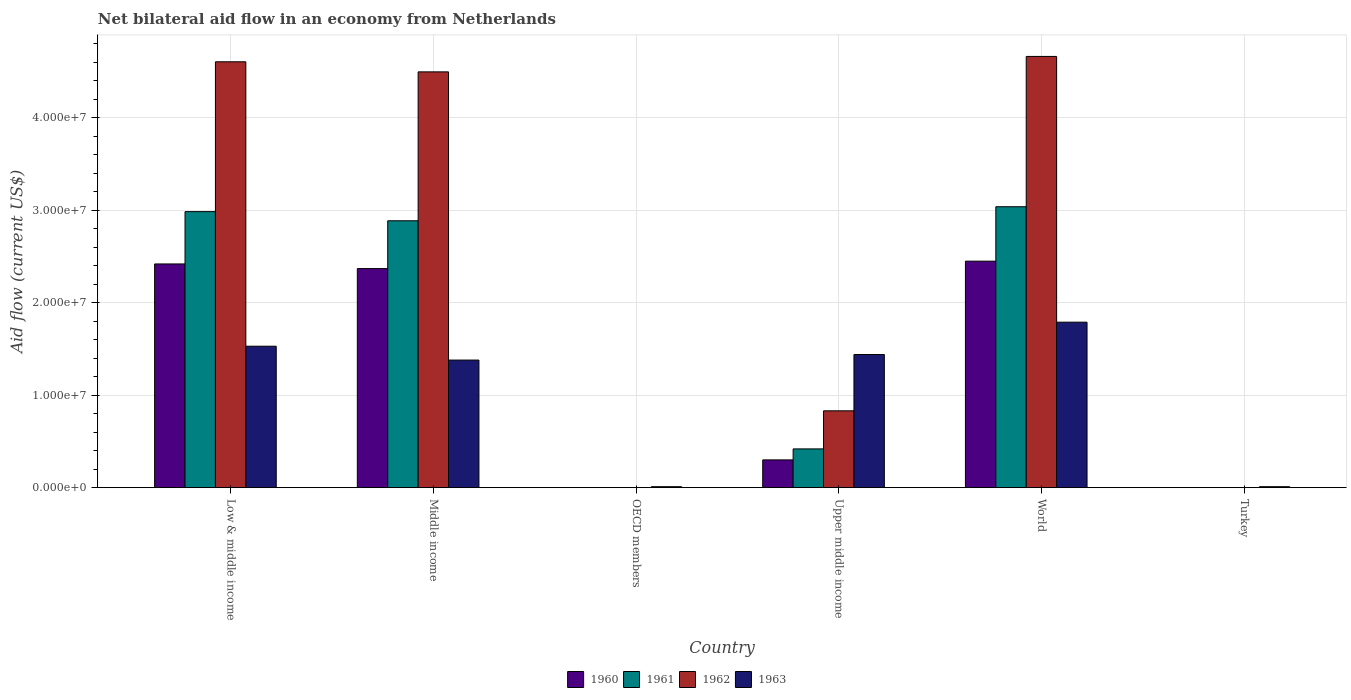How many different coloured bars are there?
Keep it short and to the point. 4. How many bars are there on the 5th tick from the right?
Your response must be concise. 4. What is the label of the 5th group of bars from the left?
Offer a terse response. World. What is the net bilateral aid flow in 1960 in Turkey?
Provide a short and direct response. 0. Across all countries, what is the maximum net bilateral aid flow in 1963?
Offer a terse response. 1.79e+07. Across all countries, what is the minimum net bilateral aid flow in 1962?
Offer a very short reply. 0. What is the total net bilateral aid flow in 1960 in the graph?
Keep it short and to the point. 7.54e+07. What is the difference between the net bilateral aid flow in 1963 in Upper middle income and the net bilateral aid flow in 1960 in Turkey?
Give a very brief answer. 1.44e+07. What is the average net bilateral aid flow in 1960 per country?
Offer a very short reply. 1.26e+07. What is the difference between the net bilateral aid flow of/in 1961 and net bilateral aid flow of/in 1963 in Upper middle income?
Give a very brief answer. -1.02e+07. What is the ratio of the net bilateral aid flow in 1963 in OECD members to that in Turkey?
Give a very brief answer. 1. Is the net bilateral aid flow in 1962 in Low & middle income less than that in Middle income?
Offer a terse response. No. What is the difference between the highest and the second highest net bilateral aid flow in 1963?
Give a very brief answer. 3.50e+06. What is the difference between the highest and the lowest net bilateral aid flow in 1961?
Provide a succinct answer. 3.04e+07. In how many countries, is the net bilateral aid flow in 1963 greater than the average net bilateral aid flow in 1963 taken over all countries?
Keep it short and to the point. 4. Is the sum of the net bilateral aid flow in 1963 in OECD members and World greater than the maximum net bilateral aid flow in 1961 across all countries?
Provide a short and direct response. No. Is it the case that in every country, the sum of the net bilateral aid flow in 1963 and net bilateral aid flow in 1961 is greater than the sum of net bilateral aid flow in 1960 and net bilateral aid flow in 1962?
Keep it short and to the point. No. How many bars are there?
Make the answer very short. 18. Are all the bars in the graph horizontal?
Your answer should be very brief. No. What is the difference between two consecutive major ticks on the Y-axis?
Make the answer very short. 1.00e+07. Where does the legend appear in the graph?
Keep it short and to the point. Bottom center. What is the title of the graph?
Give a very brief answer. Net bilateral aid flow in an economy from Netherlands. Does "2002" appear as one of the legend labels in the graph?
Provide a succinct answer. No. What is the Aid flow (current US$) in 1960 in Low & middle income?
Make the answer very short. 2.42e+07. What is the Aid flow (current US$) of 1961 in Low & middle income?
Make the answer very short. 2.99e+07. What is the Aid flow (current US$) in 1962 in Low & middle income?
Make the answer very short. 4.61e+07. What is the Aid flow (current US$) of 1963 in Low & middle income?
Your answer should be very brief. 1.53e+07. What is the Aid flow (current US$) of 1960 in Middle income?
Your response must be concise. 2.37e+07. What is the Aid flow (current US$) of 1961 in Middle income?
Give a very brief answer. 2.89e+07. What is the Aid flow (current US$) of 1962 in Middle income?
Offer a very short reply. 4.50e+07. What is the Aid flow (current US$) in 1963 in Middle income?
Offer a terse response. 1.38e+07. What is the Aid flow (current US$) in 1960 in OECD members?
Offer a very short reply. 0. What is the Aid flow (current US$) of 1962 in OECD members?
Provide a succinct answer. 0. What is the Aid flow (current US$) of 1961 in Upper middle income?
Offer a very short reply. 4.19e+06. What is the Aid flow (current US$) of 1962 in Upper middle income?
Provide a succinct answer. 8.31e+06. What is the Aid flow (current US$) of 1963 in Upper middle income?
Your response must be concise. 1.44e+07. What is the Aid flow (current US$) in 1960 in World?
Provide a short and direct response. 2.45e+07. What is the Aid flow (current US$) in 1961 in World?
Your response must be concise. 3.04e+07. What is the Aid flow (current US$) in 1962 in World?
Provide a short and direct response. 4.66e+07. What is the Aid flow (current US$) in 1963 in World?
Make the answer very short. 1.79e+07. What is the Aid flow (current US$) in 1960 in Turkey?
Ensure brevity in your answer.  0. What is the Aid flow (current US$) of 1961 in Turkey?
Provide a succinct answer. 0. What is the Aid flow (current US$) in 1962 in Turkey?
Offer a very short reply. 0. What is the Aid flow (current US$) of 1963 in Turkey?
Offer a terse response. 1.00e+05. Across all countries, what is the maximum Aid flow (current US$) in 1960?
Your answer should be compact. 2.45e+07. Across all countries, what is the maximum Aid flow (current US$) of 1961?
Your answer should be compact. 3.04e+07. Across all countries, what is the maximum Aid flow (current US$) of 1962?
Offer a very short reply. 4.66e+07. Across all countries, what is the maximum Aid flow (current US$) in 1963?
Your answer should be compact. 1.79e+07. Across all countries, what is the minimum Aid flow (current US$) in 1961?
Ensure brevity in your answer.  0. Across all countries, what is the minimum Aid flow (current US$) of 1962?
Give a very brief answer. 0. What is the total Aid flow (current US$) of 1960 in the graph?
Provide a short and direct response. 7.54e+07. What is the total Aid flow (current US$) of 1961 in the graph?
Ensure brevity in your answer.  9.33e+07. What is the total Aid flow (current US$) of 1962 in the graph?
Keep it short and to the point. 1.46e+08. What is the total Aid flow (current US$) in 1963 in the graph?
Your answer should be very brief. 6.16e+07. What is the difference between the Aid flow (current US$) in 1961 in Low & middle income and that in Middle income?
Offer a very short reply. 9.90e+05. What is the difference between the Aid flow (current US$) of 1962 in Low & middle income and that in Middle income?
Offer a very short reply. 1.09e+06. What is the difference between the Aid flow (current US$) of 1963 in Low & middle income and that in Middle income?
Your answer should be compact. 1.50e+06. What is the difference between the Aid flow (current US$) of 1963 in Low & middle income and that in OECD members?
Offer a terse response. 1.52e+07. What is the difference between the Aid flow (current US$) in 1960 in Low & middle income and that in Upper middle income?
Your answer should be very brief. 2.12e+07. What is the difference between the Aid flow (current US$) of 1961 in Low & middle income and that in Upper middle income?
Keep it short and to the point. 2.57e+07. What is the difference between the Aid flow (current US$) in 1962 in Low & middle income and that in Upper middle income?
Your answer should be compact. 3.78e+07. What is the difference between the Aid flow (current US$) of 1963 in Low & middle income and that in Upper middle income?
Offer a very short reply. 9.00e+05. What is the difference between the Aid flow (current US$) of 1960 in Low & middle income and that in World?
Provide a short and direct response. -3.00e+05. What is the difference between the Aid flow (current US$) of 1961 in Low & middle income and that in World?
Ensure brevity in your answer.  -5.30e+05. What is the difference between the Aid flow (current US$) in 1962 in Low & middle income and that in World?
Keep it short and to the point. -5.80e+05. What is the difference between the Aid flow (current US$) in 1963 in Low & middle income and that in World?
Give a very brief answer. -2.60e+06. What is the difference between the Aid flow (current US$) of 1963 in Low & middle income and that in Turkey?
Provide a short and direct response. 1.52e+07. What is the difference between the Aid flow (current US$) in 1963 in Middle income and that in OECD members?
Keep it short and to the point. 1.37e+07. What is the difference between the Aid flow (current US$) in 1960 in Middle income and that in Upper middle income?
Provide a short and direct response. 2.07e+07. What is the difference between the Aid flow (current US$) of 1961 in Middle income and that in Upper middle income?
Your response must be concise. 2.47e+07. What is the difference between the Aid flow (current US$) of 1962 in Middle income and that in Upper middle income?
Keep it short and to the point. 3.67e+07. What is the difference between the Aid flow (current US$) in 1963 in Middle income and that in Upper middle income?
Your answer should be very brief. -6.00e+05. What is the difference between the Aid flow (current US$) in 1960 in Middle income and that in World?
Your answer should be very brief. -8.00e+05. What is the difference between the Aid flow (current US$) of 1961 in Middle income and that in World?
Ensure brevity in your answer.  -1.52e+06. What is the difference between the Aid flow (current US$) in 1962 in Middle income and that in World?
Give a very brief answer. -1.67e+06. What is the difference between the Aid flow (current US$) of 1963 in Middle income and that in World?
Offer a terse response. -4.10e+06. What is the difference between the Aid flow (current US$) in 1963 in Middle income and that in Turkey?
Your answer should be compact. 1.37e+07. What is the difference between the Aid flow (current US$) in 1963 in OECD members and that in Upper middle income?
Your answer should be compact. -1.43e+07. What is the difference between the Aid flow (current US$) of 1963 in OECD members and that in World?
Keep it short and to the point. -1.78e+07. What is the difference between the Aid flow (current US$) of 1963 in OECD members and that in Turkey?
Ensure brevity in your answer.  0. What is the difference between the Aid flow (current US$) of 1960 in Upper middle income and that in World?
Ensure brevity in your answer.  -2.15e+07. What is the difference between the Aid flow (current US$) in 1961 in Upper middle income and that in World?
Keep it short and to the point. -2.62e+07. What is the difference between the Aid flow (current US$) in 1962 in Upper middle income and that in World?
Provide a short and direct response. -3.83e+07. What is the difference between the Aid flow (current US$) in 1963 in Upper middle income and that in World?
Make the answer very short. -3.50e+06. What is the difference between the Aid flow (current US$) in 1963 in Upper middle income and that in Turkey?
Make the answer very short. 1.43e+07. What is the difference between the Aid flow (current US$) of 1963 in World and that in Turkey?
Provide a short and direct response. 1.78e+07. What is the difference between the Aid flow (current US$) of 1960 in Low & middle income and the Aid flow (current US$) of 1961 in Middle income?
Provide a succinct answer. -4.67e+06. What is the difference between the Aid flow (current US$) in 1960 in Low & middle income and the Aid flow (current US$) in 1962 in Middle income?
Provide a short and direct response. -2.08e+07. What is the difference between the Aid flow (current US$) in 1960 in Low & middle income and the Aid flow (current US$) in 1963 in Middle income?
Your answer should be compact. 1.04e+07. What is the difference between the Aid flow (current US$) of 1961 in Low & middle income and the Aid flow (current US$) of 1962 in Middle income?
Keep it short and to the point. -1.51e+07. What is the difference between the Aid flow (current US$) in 1961 in Low & middle income and the Aid flow (current US$) in 1963 in Middle income?
Your answer should be compact. 1.61e+07. What is the difference between the Aid flow (current US$) of 1962 in Low & middle income and the Aid flow (current US$) of 1963 in Middle income?
Make the answer very short. 3.23e+07. What is the difference between the Aid flow (current US$) in 1960 in Low & middle income and the Aid flow (current US$) in 1963 in OECD members?
Your answer should be compact. 2.41e+07. What is the difference between the Aid flow (current US$) in 1961 in Low & middle income and the Aid flow (current US$) in 1963 in OECD members?
Ensure brevity in your answer.  2.98e+07. What is the difference between the Aid flow (current US$) of 1962 in Low & middle income and the Aid flow (current US$) of 1963 in OECD members?
Your answer should be compact. 4.60e+07. What is the difference between the Aid flow (current US$) in 1960 in Low & middle income and the Aid flow (current US$) in 1961 in Upper middle income?
Make the answer very short. 2.00e+07. What is the difference between the Aid flow (current US$) in 1960 in Low & middle income and the Aid flow (current US$) in 1962 in Upper middle income?
Give a very brief answer. 1.59e+07. What is the difference between the Aid flow (current US$) in 1960 in Low & middle income and the Aid flow (current US$) in 1963 in Upper middle income?
Make the answer very short. 9.80e+06. What is the difference between the Aid flow (current US$) of 1961 in Low & middle income and the Aid flow (current US$) of 1962 in Upper middle income?
Give a very brief answer. 2.16e+07. What is the difference between the Aid flow (current US$) of 1961 in Low & middle income and the Aid flow (current US$) of 1963 in Upper middle income?
Offer a terse response. 1.55e+07. What is the difference between the Aid flow (current US$) of 1962 in Low & middle income and the Aid flow (current US$) of 1963 in Upper middle income?
Your answer should be very brief. 3.17e+07. What is the difference between the Aid flow (current US$) in 1960 in Low & middle income and the Aid flow (current US$) in 1961 in World?
Your response must be concise. -6.19e+06. What is the difference between the Aid flow (current US$) in 1960 in Low & middle income and the Aid flow (current US$) in 1962 in World?
Offer a terse response. -2.24e+07. What is the difference between the Aid flow (current US$) in 1960 in Low & middle income and the Aid flow (current US$) in 1963 in World?
Your response must be concise. 6.30e+06. What is the difference between the Aid flow (current US$) of 1961 in Low & middle income and the Aid flow (current US$) of 1962 in World?
Your answer should be very brief. -1.68e+07. What is the difference between the Aid flow (current US$) in 1961 in Low & middle income and the Aid flow (current US$) in 1963 in World?
Provide a short and direct response. 1.20e+07. What is the difference between the Aid flow (current US$) of 1962 in Low & middle income and the Aid flow (current US$) of 1963 in World?
Make the answer very short. 2.82e+07. What is the difference between the Aid flow (current US$) in 1960 in Low & middle income and the Aid flow (current US$) in 1963 in Turkey?
Keep it short and to the point. 2.41e+07. What is the difference between the Aid flow (current US$) of 1961 in Low & middle income and the Aid flow (current US$) of 1963 in Turkey?
Offer a terse response. 2.98e+07. What is the difference between the Aid flow (current US$) in 1962 in Low & middle income and the Aid flow (current US$) in 1963 in Turkey?
Ensure brevity in your answer.  4.60e+07. What is the difference between the Aid flow (current US$) in 1960 in Middle income and the Aid flow (current US$) in 1963 in OECD members?
Offer a very short reply. 2.36e+07. What is the difference between the Aid flow (current US$) of 1961 in Middle income and the Aid flow (current US$) of 1963 in OECD members?
Give a very brief answer. 2.88e+07. What is the difference between the Aid flow (current US$) in 1962 in Middle income and the Aid flow (current US$) in 1963 in OECD members?
Make the answer very short. 4.49e+07. What is the difference between the Aid flow (current US$) in 1960 in Middle income and the Aid flow (current US$) in 1961 in Upper middle income?
Your response must be concise. 1.95e+07. What is the difference between the Aid flow (current US$) of 1960 in Middle income and the Aid flow (current US$) of 1962 in Upper middle income?
Your answer should be compact. 1.54e+07. What is the difference between the Aid flow (current US$) in 1960 in Middle income and the Aid flow (current US$) in 1963 in Upper middle income?
Ensure brevity in your answer.  9.30e+06. What is the difference between the Aid flow (current US$) in 1961 in Middle income and the Aid flow (current US$) in 1962 in Upper middle income?
Provide a short and direct response. 2.06e+07. What is the difference between the Aid flow (current US$) of 1961 in Middle income and the Aid flow (current US$) of 1963 in Upper middle income?
Offer a terse response. 1.45e+07. What is the difference between the Aid flow (current US$) in 1962 in Middle income and the Aid flow (current US$) in 1963 in Upper middle income?
Ensure brevity in your answer.  3.06e+07. What is the difference between the Aid flow (current US$) of 1960 in Middle income and the Aid flow (current US$) of 1961 in World?
Provide a succinct answer. -6.69e+06. What is the difference between the Aid flow (current US$) in 1960 in Middle income and the Aid flow (current US$) in 1962 in World?
Offer a terse response. -2.30e+07. What is the difference between the Aid flow (current US$) in 1960 in Middle income and the Aid flow (current US$) in 1963 in World?
Keep it short and to the point. 5.80e+06. What is the difference between the Aid flow (current US$) in 1961 in Middle income and the Aid flow (current US$) in 1962 in World?
Offer a very short reply. -1.78e+07. What is the difference between the Aid flow (current US$) in 1961 in Middle income and the Aid flow (current US$) in 1963 in World?
Ensure brevity in your answer.  1.10e+07. What is the difference between the Aid flow (current US$) in 1962 in Middle income and the Aid flow (current US$) in 1963 in World?
Give a very brief answer. 2.71e+07. What is the difference between the Aid flow (current US$) of 1960 in Middle income and the Aid flow (current US$) of 1963 in Turkey?
Give a very brief answer. 2.36e+07. What is the difference between the Aid flow (current US$) in 1961 in Middle income and the Aid flow (current US$) in 1963 in Turkey?
Provide a succinct answer. 2.88e+07. What is the difference between the Aid flow (current US$) in 1962 in Middle income and the Aid flow (current US$) in 1963 in Turkey?
Your answer should be very brief. 4.49e+07. What is the difference between the Aid flow (current US$) in 1960 in Upper middle income and the Aid flow (current US$) in 1961 in World?
Offer a very short reply. -2.74e+07. What is the difference between the Aid flow (current US$) in 1960 in Upper middle income and the Aid flow (current US$) in 1962 in World?
Provide a short and direct response. -4.36e+07. What is the difference between the Aid flow (current US$) in 1960 in Upper middle income and the Aid flow (current US$) in 1963 in World?
Your answer should be very brief. -1.49e+07. What is the difference between the Aid flow (current US$) of 1961 in Upper middle income and the Aid flow (current US$) of 1962 in World?
Keep it short and to the point. -4.25e+07. What is the difference between the Aid flow (current US$) in 1961 in Upper middle income and the Aid flow (current US$) in 1963 in World?
Give a very brief answer. -1.37e+07. What is the difference between the Aid flow (current US$) of 1962 in Upper middle income and the Aid flow (current US$) of 1963 in World?
Your response must be concise. -9.59e+06. What is the difference between the Aid flow (current US$) of 1960 in Upper middle income and the Aid flow (current US$) of 1963 in Turkey?
Your answer should be very brief. 2.90e+06. What is the difference between the Aid flow (current US$) in 1961 in Upper middle income and the Aid flow (current US$) in 1963 in Turkey?
Offer a terse response. 4.09e+06. What is the difference between the Aid flow (current US$) in 1962 in Upper middle income and the Aid flow (current US$) in 1963 in Turkey?
Ensure brevity in your answer.  8.21e+06. What is the difference between the Aid flow (current US$) of 1960 in World and the Aid flow (current US$) of 1963 in Turkey?
Your answer should be compact. 2.44e+07. What is the difference between the Aid flow (current US$) in 1961 in World and the Aid flow (current US$) in 1963 in Turkey?
Make the answer very short. 3.03e+07. What is the difference between the Aid flow (current US$) in 1962 in World and the Aid flow (current US$) in 1963 in Turkey?
Make the answer very short. 4.66e+07. What is the average Aid flow (current US$) in 1960 per country?
Give a very brief answer. 1.26e+07. What is the average Aid flow (current US$) in 1961 per country?
Give a very brief answer. 1.56e+07. What is the average Aid flow (current US$) of 1962 per country?
Give a very brief answer. 2.43e+07. What is the average Aid flow (current US$) in 1963 per country?
Give a very brief answer. 1.03e+07. What is the difference between the Aid flow (current US$) of 1960 and Aid flow (current US$) of 1961 in Low & middle income?
Your answer should be compact. -5.66e+06. What is the difference between the Aid flow (current US$) in 1960 and Aid flow (current US$) in 1962 in Low & middle income?
Provide a short and direct response. -2.19e+07. What is the difference between the Aid flow (current US$) in 1960 and Aid flow (current US$) in 1963 in Low & middle income?
Give a very brief answer. 8.90e+06. What is the difference between the Aid flow (current US$) of 1961 and Aid flow (current US$) of 1962 in Low & middle income?
Provide a succinct answer. -1.62e+07. What is the difference between the Aid flow (current US$) in 1961 and Aid flow (current US$) in 1963 in Low & middle income?
Keep it short and to the point. 1.46e+07. What is the difference between the Aid flow (current US$) in 1962 and Aid flow (current US$) in 1963 in Low & middle income?
Ensure brevity in your answer.  3.08e+07. What is the difference between the Aid flow (current US$) of 1960 and Aid flow (current US$) of 1961 in Middle income?
Provide a succinct answer. -5.17e+06. What is the difference between the Aid flow (current US$) of 1960 and Aid flow (current US$) of 1962 in Middle income?
Offer a very short reply. -2.13e+07. What is the difference between the Aid flow (current US$) in 1960 and Aid flow (current US$) in 1963 in Middle income?
Make the answer very short. 9.90e+06. What is the difference between the Aid flow (current US$) in 1961 and Aid flow (current US$) in 1962 in Middle income?
Your answer should be compact. -1.61e+07. What is the difference between the Aid flow (current US$) of 1961 and Aid flow (current US$) of 1963 in Middle income?
Offer a very short reply. 1.51e+07. What is the difference between the Aid flow (current US$) of 1962 and Aid flow (current US$) of 1963 in Middle income?
Your answer should be very brief. 3.12e+07. What is the difference between the Aid flow (current US$) in 1960 and Aid flow (current US$) in 1961 in Upper middle income?
Your response must be concise. -1.19e+06. What is the difference between the Aid flow (current US$) of 1960 and Aid flow (current US$) of 1962 in Upper middle income?
Make the answer very short. -5.31e+06. What is the difference between the Aid flow (current US$) of 1960 and Aid flow (current US$) of 1963 in Upper middle income?
Ensure brevity in your answer.  -1.14e+07. What is the difference between the Aid flow (current US$) of 1961 and Aid flow (current US$) of 1962 in Upper middle income?
Make the answer very short. -4.12e+06. What is the difference between the Aid flow (current US$) of 1961 and Aid flow (current US$) of 1963 in Upper middle income?
Give a very brief answer. -1.02e+07. What is the difference between the Aid flow (current US$) of 1962 and Aid flow (current US$) of 1963 in Upper middle income?
Your response must be concise. -6.09e+06. What is the difference between the Aid flow (current US$) in 1960 and Aid flow (current US$) in 1961 in World?
Provide a short and direct response. -5.89e+06. What is the difference between the Aid flow (current US$) of 1960 and Aid flow (current US$) of 1962 in World?
Keep it short and to the point. -2.22e+07. What is the difference between the Aid flow (current US$) in 1960 and Aid flow (current US$) in 1963 in World?
Offer a terse response. 6.60e+06. What is the difference between the Aid flow (current US$) of 1961 and Aid flow (current US$) of 1962 in World?
Provide a short and direct response. -1.63e+07. What is the difference between the Aid flow (current US$) in 1961 and Aid flow (current US$) in 1963 in World?
Your answer should be very brief. 1.25e+07. What is the difference between the Aid flow (current US$) in 1962 and Aid flow (current US$) in 1963 in World?
Your answer should be very brief. 2.88e+07. What is the ratio of the Aid flow (current US$) of 1960 in Low & middle income to that in Middle income?
Your response must be concise. 1.02. What is the ratio of the Aid flow (current US$) in 1961 in Low & middle income to that in Middle income?
Provide a short and direct response. 1.03. What is the ratio of the Aid flow (current US$) in 1962 in Low & middle income to that in Middle income?
Make the answer very short. 1.02. What is the ratio of the Aid flow (current US$) in 1963 in Low & middle income to that in Middle income?
Your answer should be very brief. 1.11. What is the ratio of the Aid flow (current US$) of 1963 in Low & middle income to that in OECD members?
Ensure brevity in your answer.  153. What is the ratio of the Aid flow (current US$) of 1960 in Low & middle income to that in Upper middle income?
Offer a very short reply. 8.07. What is the ratio of the Aid flow (current US$) of 1961 in Low & middle income to that in Upper middle income?
Provide a succinct answer. 7.13. What is the ratio of the Aid flow (current US$) of 1962 in Low & middle income to that in Upper middle income?
Your answer should be very brief. 5.54. What is the ratio of the Aid flow (current US$) of 1963 in Low & middle income to that in Upper middle income?
Give a very brief answer. 1.06. What is the ratio of the Aid flow (current US$) in 1961 in Low & middle income to that in World?
Provide a short and direct response. 0.98. What is the ratio of the Aid flow (current US$) of 1962 in Low & middle income to that in World?
Make the answer very short. 0.99. What is the ratio of the Aid flow (current US$) in 1963 in Low & middle income to that in World?
Your response must be concise. 0.85. What is the ratio of the Aid flow (current US$) in 1963 in Low & middle income to that in Turkey?
Offer a terse response. 153. What is the ratio of the Aid flow (current US$) of 1963 in Middle income to that in OECD members?
Ensure brevity in your answer.  138. What is the ratio of the Aid flow (current US$) of 1960 in Middle income to that in Upper middle income?
Offer a very short reply. 7.9. What is the ratio of the Aid flow (current US$) of 1961 in Middle income to that in Upper middle income?
Keep it short and to the point. 6.89. What is the ratio of the Aid flow (current US$) in 1962 in Middle income to that in Upper middle income?
Offer a terse response. 5.41. What is the ratio of the Aid flow (current US$) of 1963 in Middle income to that in Upper middle income?
Provide a short and direct response. 0.96. What is the ratio of the Aid flow (current US$) in 1960 in Middle income to that in World?
Offer a terse response. 0.97. What is the ratio of the Aid flow (current US$) in 1961 in Middle income to that in World?
Give a very brief answer. 0.95. What is the ratio of the Aid flow (current US$) in 1962 in Middle income to that in World?
Your answer should be compact. 0.96. What is the ratio of the Aid flow (current US$) in 1963 in Middle income to that in World?
Provide a short and direct response. 0.77. What is the ratio of the Aid flow (current US$) in 1963 in Middle income to that in Turkey?
Your answer should be very brief. 138. What is the ratio of the Aid flow (current US$) of 1963 in OECD members to that in Upper middle income?
Your answer should be compact. 0.01. What is the ratio of the Aid flow (current US$) of 1963 in OECD members to that in World?
Make the answer very short. 0.01. What is the ratio of the Aid flow (current US$) in 1963 in OECD members to that in Turkey?
Your answer should be very brief. 1. What is the ratio of the Aid flow (current US$) of 1960 in Upper middle income to that in World?
Your response must be concise. 0.12. What is the ratio of the Aid flow (current US$) of 1961 in Upper middle income to that in World?
Offer a very short reply. 0.14. What is the ratio of the Aid flow (current US$) of 1962 in Upper middle income to that in World?
Keep it short and to the point. 0.18. What is the ratio of the Aid flow (current US$) in 1963 in Upper middle income to that in World?
Make the answer very short. 0.8. What is the ratio of the Aid flow (current US$) of 1963 in Upper middle income to that in Turkey?
Your answer should be very brief. 144. What is the ratio of the Aid flow (current US$) of 1963 in World to that in Turkey?
Give a very brief answer. 179. What is the difference between the highest and the second highest Aid flow (current US$) of 1960?
Keep it short and to the point. 3.00e+05. What is the difference between the highest and the second highest Aid flow (current US$) in 1961?
Offer a terse response. 5.30e+05. What is the difference between the highest and the second highest Aid flow (current US$) in 1962?
Offer a very short reply. 5.80e+05. What is the difference between the highest and the second highest Aid flow (current US$) in 1963?
Your answer should be very brief. 2.60e+06. What is the difference between the highest and the lowest Aid flow (current US$) in 1960?
Provide a succinct answer. 2.45e+07. What is the difference between the highest and the lowest Aid flow (current US$) of 1961?
Keep it short and to the point. 3.04e+07. What is the difference between the highest and the lowest Aid flow (current US$) in 1962?
Keep it short and to the point. 4.66e+07. What is the difference between the highest and the lowest Aid flow (current US$) of 1963?
Your response must be concise. 1.78e+07. 